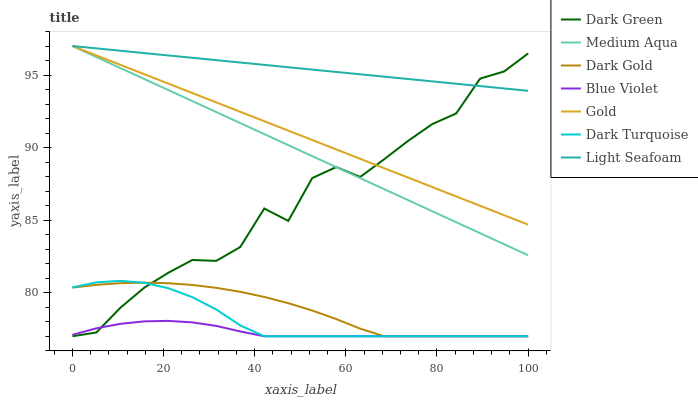Does Dark Gold have the minimum area under the curve?
Answer yes or no. No. Does Dark Gold have the maximum area under the curve?
Answer yes or no. No. Is Dark Gold the smoothest?
Answer yes or no. No. Is Dark Gold the roughest?
Answer yes or no. No. Does Medium Aqua have the lowest value?
Answer yes or no. No. Does Dark Gold have the highest value?
Answer yes or no. No. Is Blue Violet less than Medium Aqua?
Answer yes or no. Yes. Is Light Seafoam greater than Dark Turquoise?
Answer yes or no. Yes. Does Blue Violet intersect Medium Aqua?
Answer yes or no. No. 